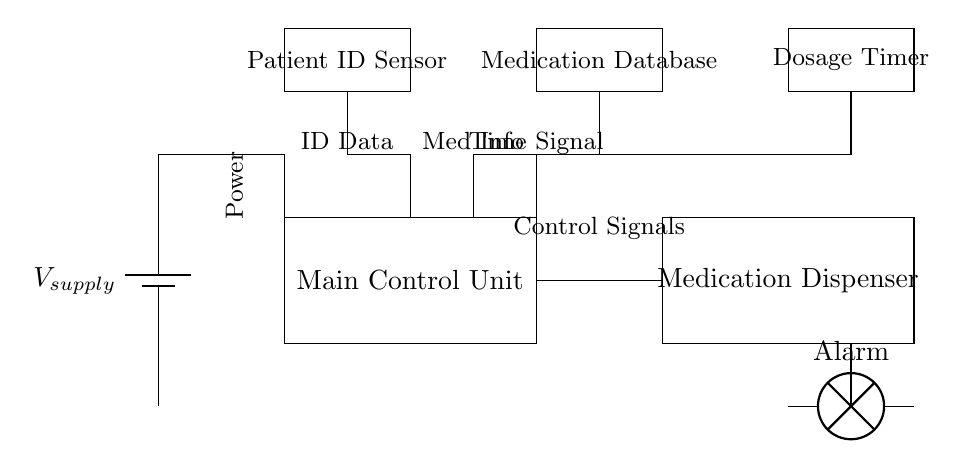What is the main component responsible for dispensing medication? The main component that dispenses medication is labeled as the Medication Dispenser in the circuit diagram. This component is specifically highlighted and identified within the rectangle in the circuit.
Answer: Medication Dispenser What does the timer control in this circuit? The timer controls the dosage timing, which is indicated by the Dosage Timer component in the circuit. It is responsible for ensuring that medication is dispensed at the correct intervals.
Answer: Dosage Timing How many main components are shown in this circuit? Counting the rectangles in the circuit diagram, there are five main components: the Power Supply, Main Control Unit, Medication Dispenser, Patient ID Sensor, Medication Database, and Dosage Timer.
Answer: Five What type of alarm is included in this circuit? The circuit includes a lamp alarm, as denoted by the label Alarm in the circuit diagram. It suggests an alert mechanism within the control circuit.
Answer: Lamp What type of data does the Patient ID Sensor process? The Patient ID Sensor processes ID data, which is explicitly labeled in the circuit diagram, indicating the type of information it manages to identify patients.
Answer: ID Data How is the Main Control Unit connected to the Medication Dispenser? The Main Control Unit is directly connected to the Medication Dispenser via control signals, shown as a line connecting the two components in the circuit diagram.
Answer: Control Signals What is the function of the Medication Database in this circuit? The Medication Database holds medication information, as indicated in the circuit. This component plays a critical role in retrieving the relevant data about medications for dispensing.
Answer: Medication Information 